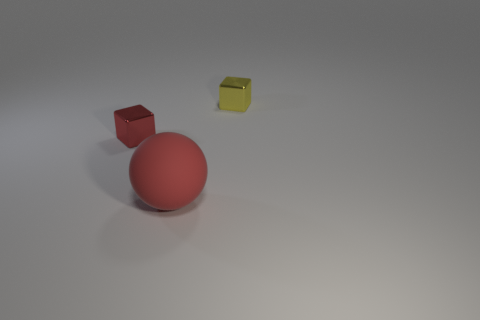Add 3 tiny red blocks. How many objects exist? 6 Subtract all blocks. How many objects are left? 1 Subtract 2 blocks. How many blocks are left? 0 Subtract all gray blocks. Subtract all blue cylinders. How many blocks are left? 2 Subtract all small rubber balls. Subtract all small metal blocks. How many objects are left? 1 Add 2 big matte things. How many big matte things are left? 3 Add 1 large red objects. How many large red objects exist? 2 Subtract 0 cyan balls. How many objects are left? 3 